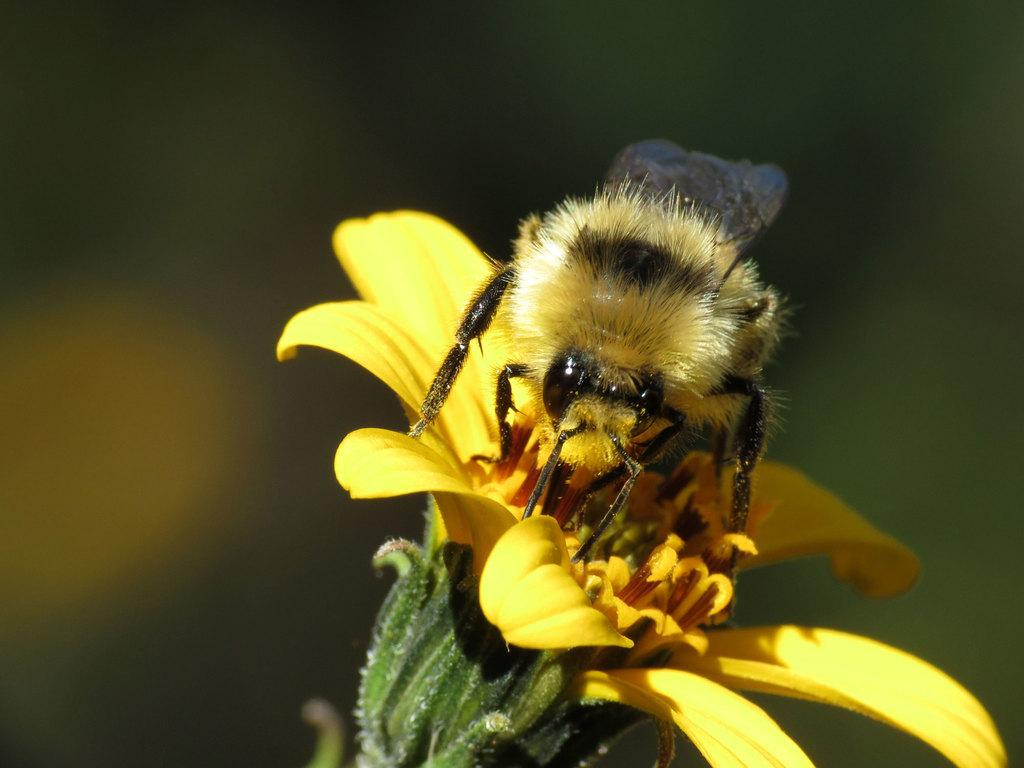What is the main subject of the image? There is an insect on a yellow flower in the image. Can you describe the flower in more detail? The flower has flower buds on it. How would you describe the background of the image? The background of the image is blurred. What type of power source can be seen near the airport in the image? There is no airport or power source present in the image; it features an insect on a yellow flower with a blurred background. 